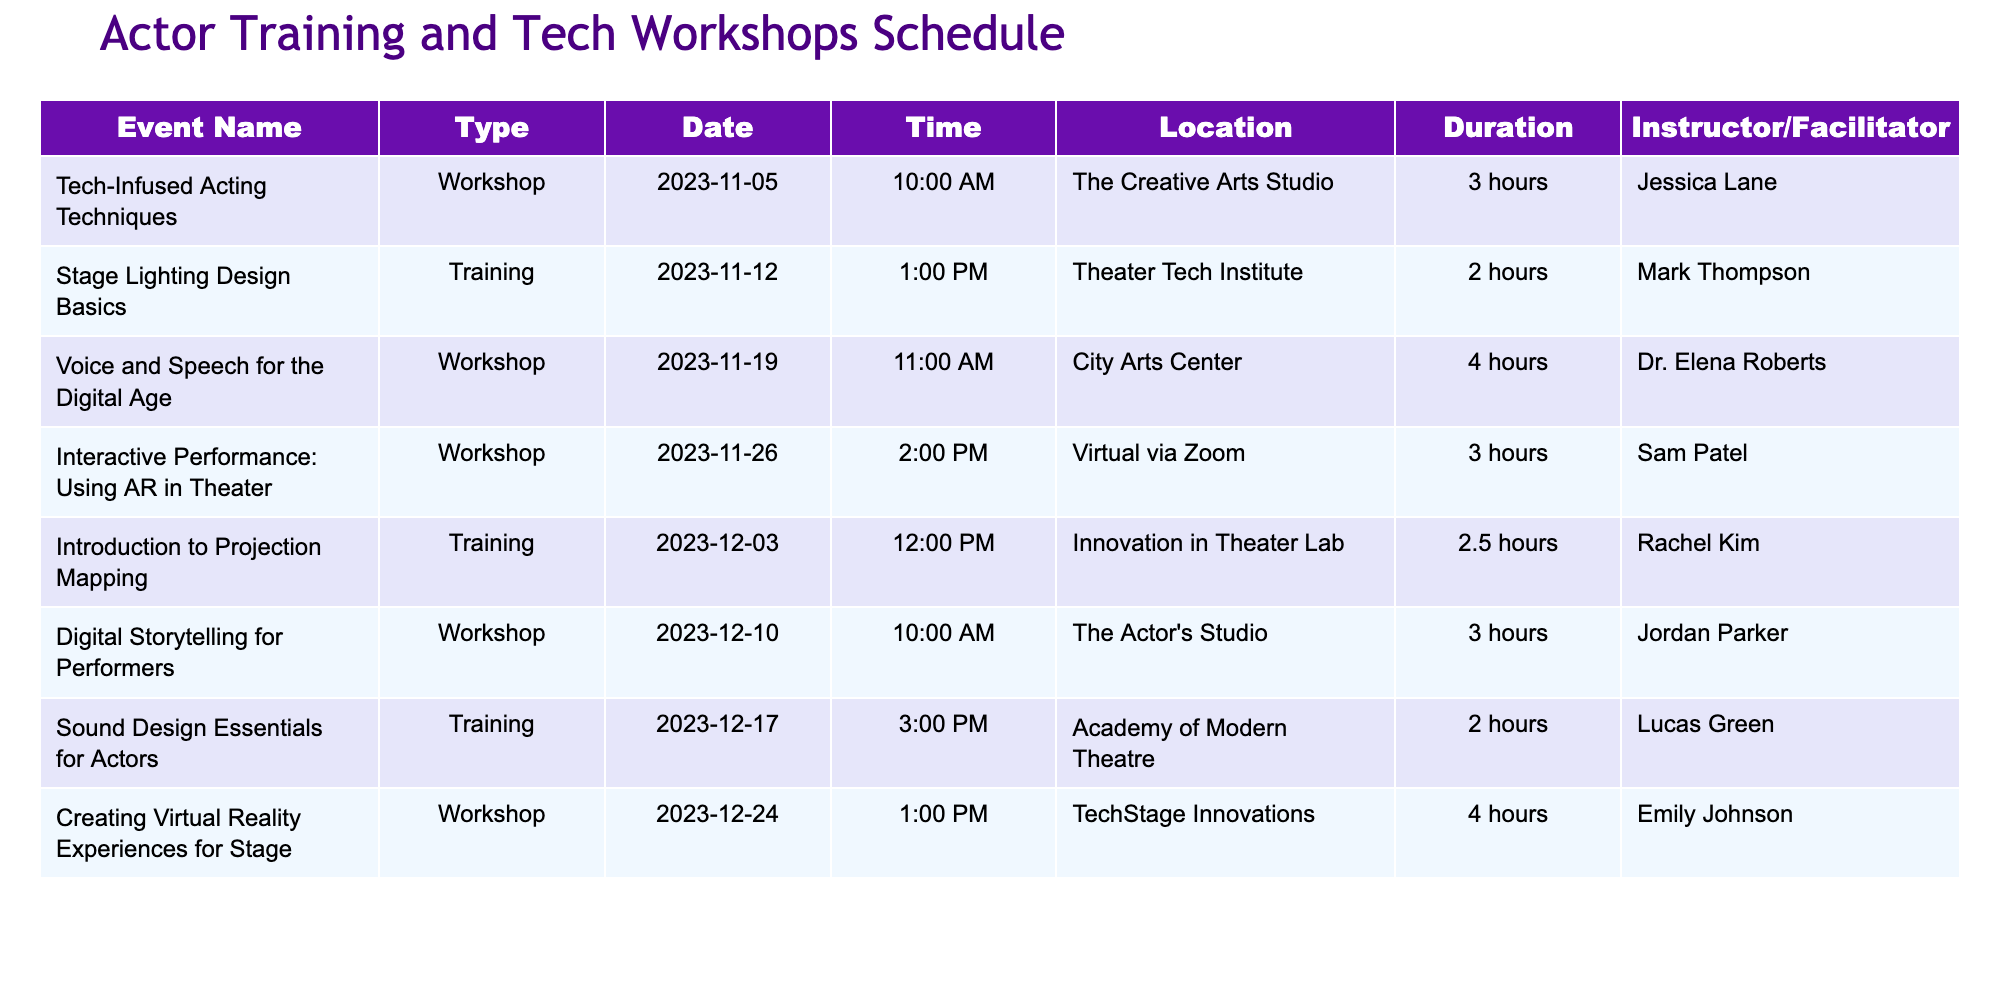What is the duration of the "Voice and Speech for the Digital Age" workshop? The duration of the workshop is listed in the table under the "Duration" column. For "Voice and Speech for the Digital Age," it shows "4 hours."
Answer: 4 hours Who is the facilitator for the "Creating Virtual Reality Experiences for Stage" workshop? To find this, I look under the "Instructor/Facilitator" column in the row corresponding to the "Creating Virtual Reality Experiences for Stage" workshop. It states "Emily Johnson."
Answer: Emily Johnson Is there a workshop scheduled before December? By checking the "Date" column, I see that there is a workshop scheduled on "2023-11-05" called "Tech-Infused Acting Techniques." Therefore, there is indeed a workshop scheduled before December.
Answer: Yes How many hours of training are scheduled for December 2023? I check the "Duration" column for the training sessions in December. The "Introduction to Projection Mapping" is for "2.5 hours," and "Sound Design Essentials for Actors" is "2 hours." Adding these gives 2.5 + 2 = 4.5 hours.
Answer: 4.5 hours What is the latest event in the schedule? To find the latest event, I compare the dates listed in the "Date" column. The latest date is "2023-12-24," which corresponds to the "Creating Virtual Reality Experiences for Stage."
Answer: Creating Virtual Reality Experiences for Stage How many workshops are longer than 3 hours? I go through the "Duration" column for the workshops and identify that "Voice and Speech for the Digital Age" is for "4 hours," and "Creating Virtual Reality Experiences for Stage" is also "4 hours." This gives a total of 2 workshops longer than 3 hours.
Answer: 2 workshops Are there any workshops taking place virtually? I scan the "Location" column for entries mentioning "Virtual via Zoom." The "Interactive Performance: Using AR in Theater" is listed as virtual, confirming that there is at least one workshop conducted online.
Answer: Yes Which event takes place at "The Actor's Studio"? I search the "Location" column for "The Actor's Studio." The event "Digital Storytelling for Performers" is associated with this location.
Answer: Digital Storytelling for Performers 